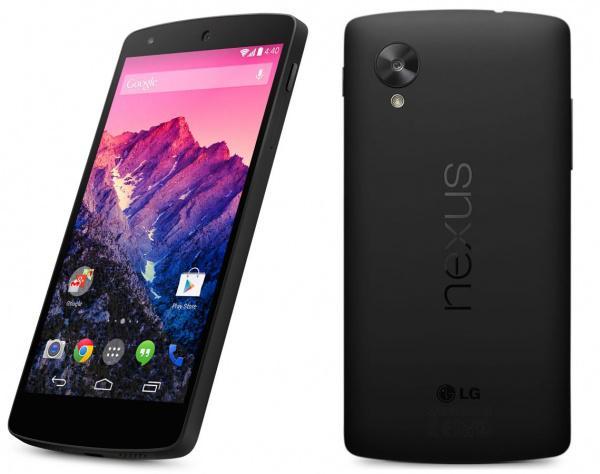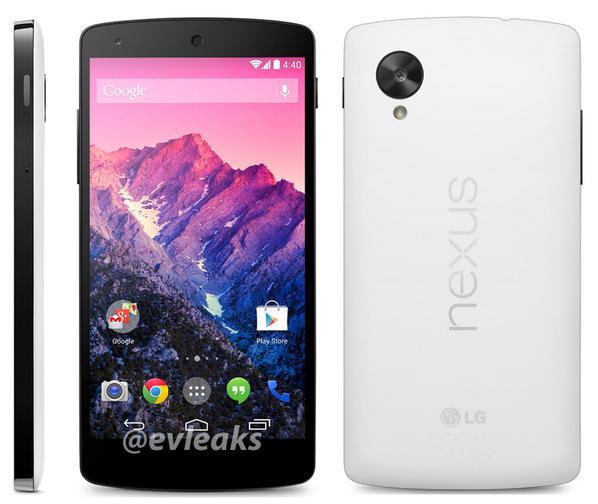The first image is the image on the left, the second image is the image on the right. For the images shown, is this caption "There is no less than five phones." true? Answer yes or no. Yes. The first image is the image on the left, the second image is the image on the right. Analyze the images presented: Is the assertion "There are no less than five phones." valid? Answer yes or no. Yes. 